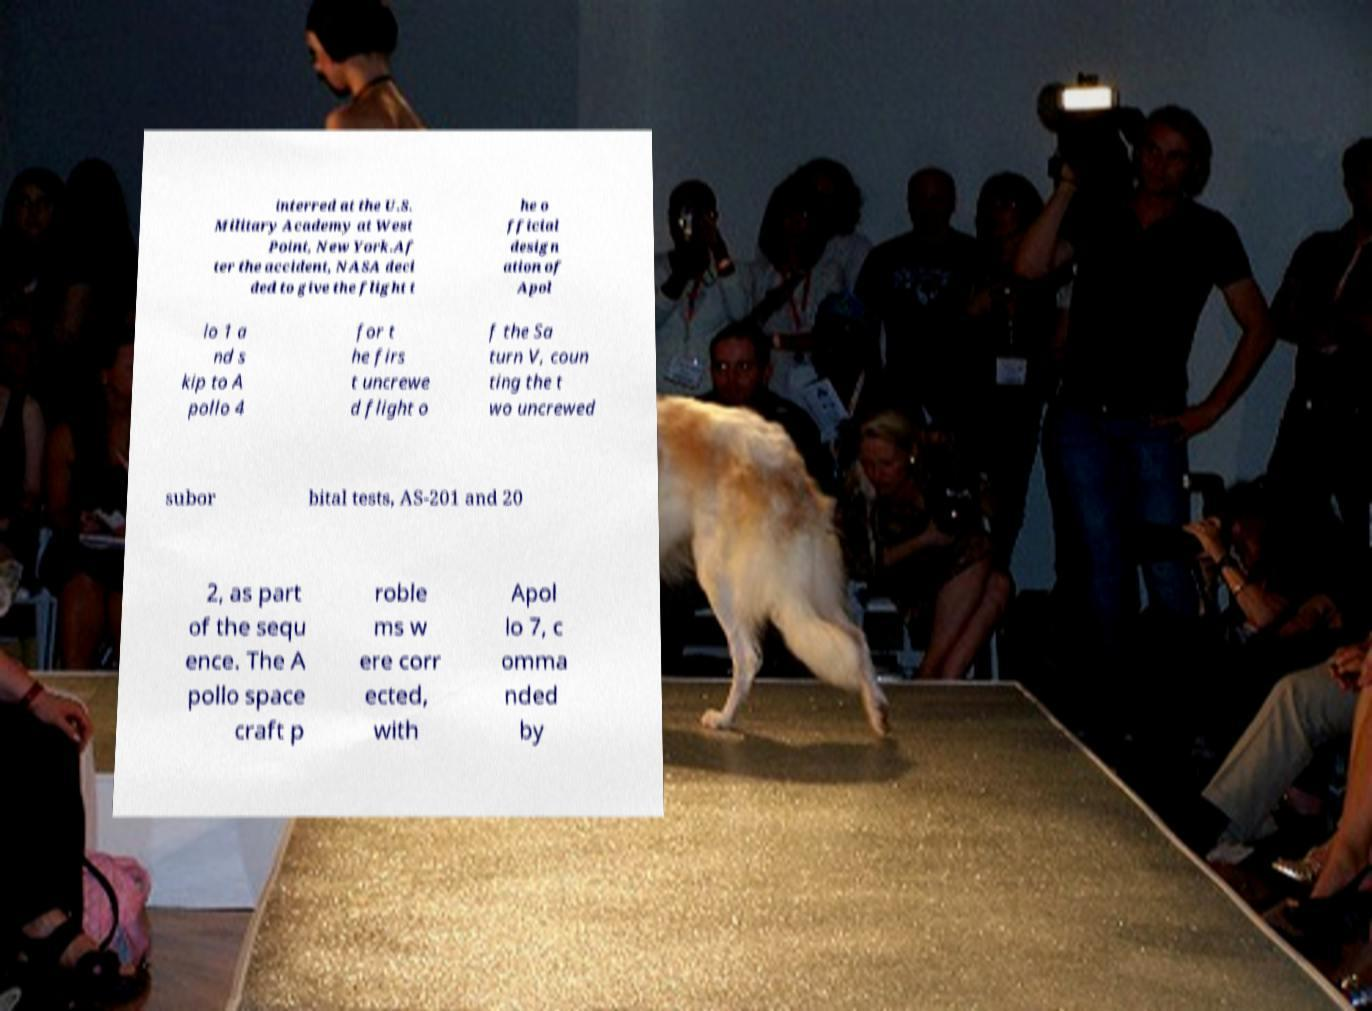For documentation purposes, I need the text within this image transcribed. Could you provide that? interred at the U.S. Military Academy at West Point, New York.Af ter the accident, NASA deci ded to give the flight t he o fficial design ation of Apol lo 1 a nd s kip to A pollo 4 for t he firs t uncrewe d flight o f the Sa turn V, coun ting the t wo uncrewed subor bital tests, AS-201 and 20 2, as part of the sequ ence. The A pollo space craft p roble ms w ere corr ected, with Apol lo 7, c omma nded by 